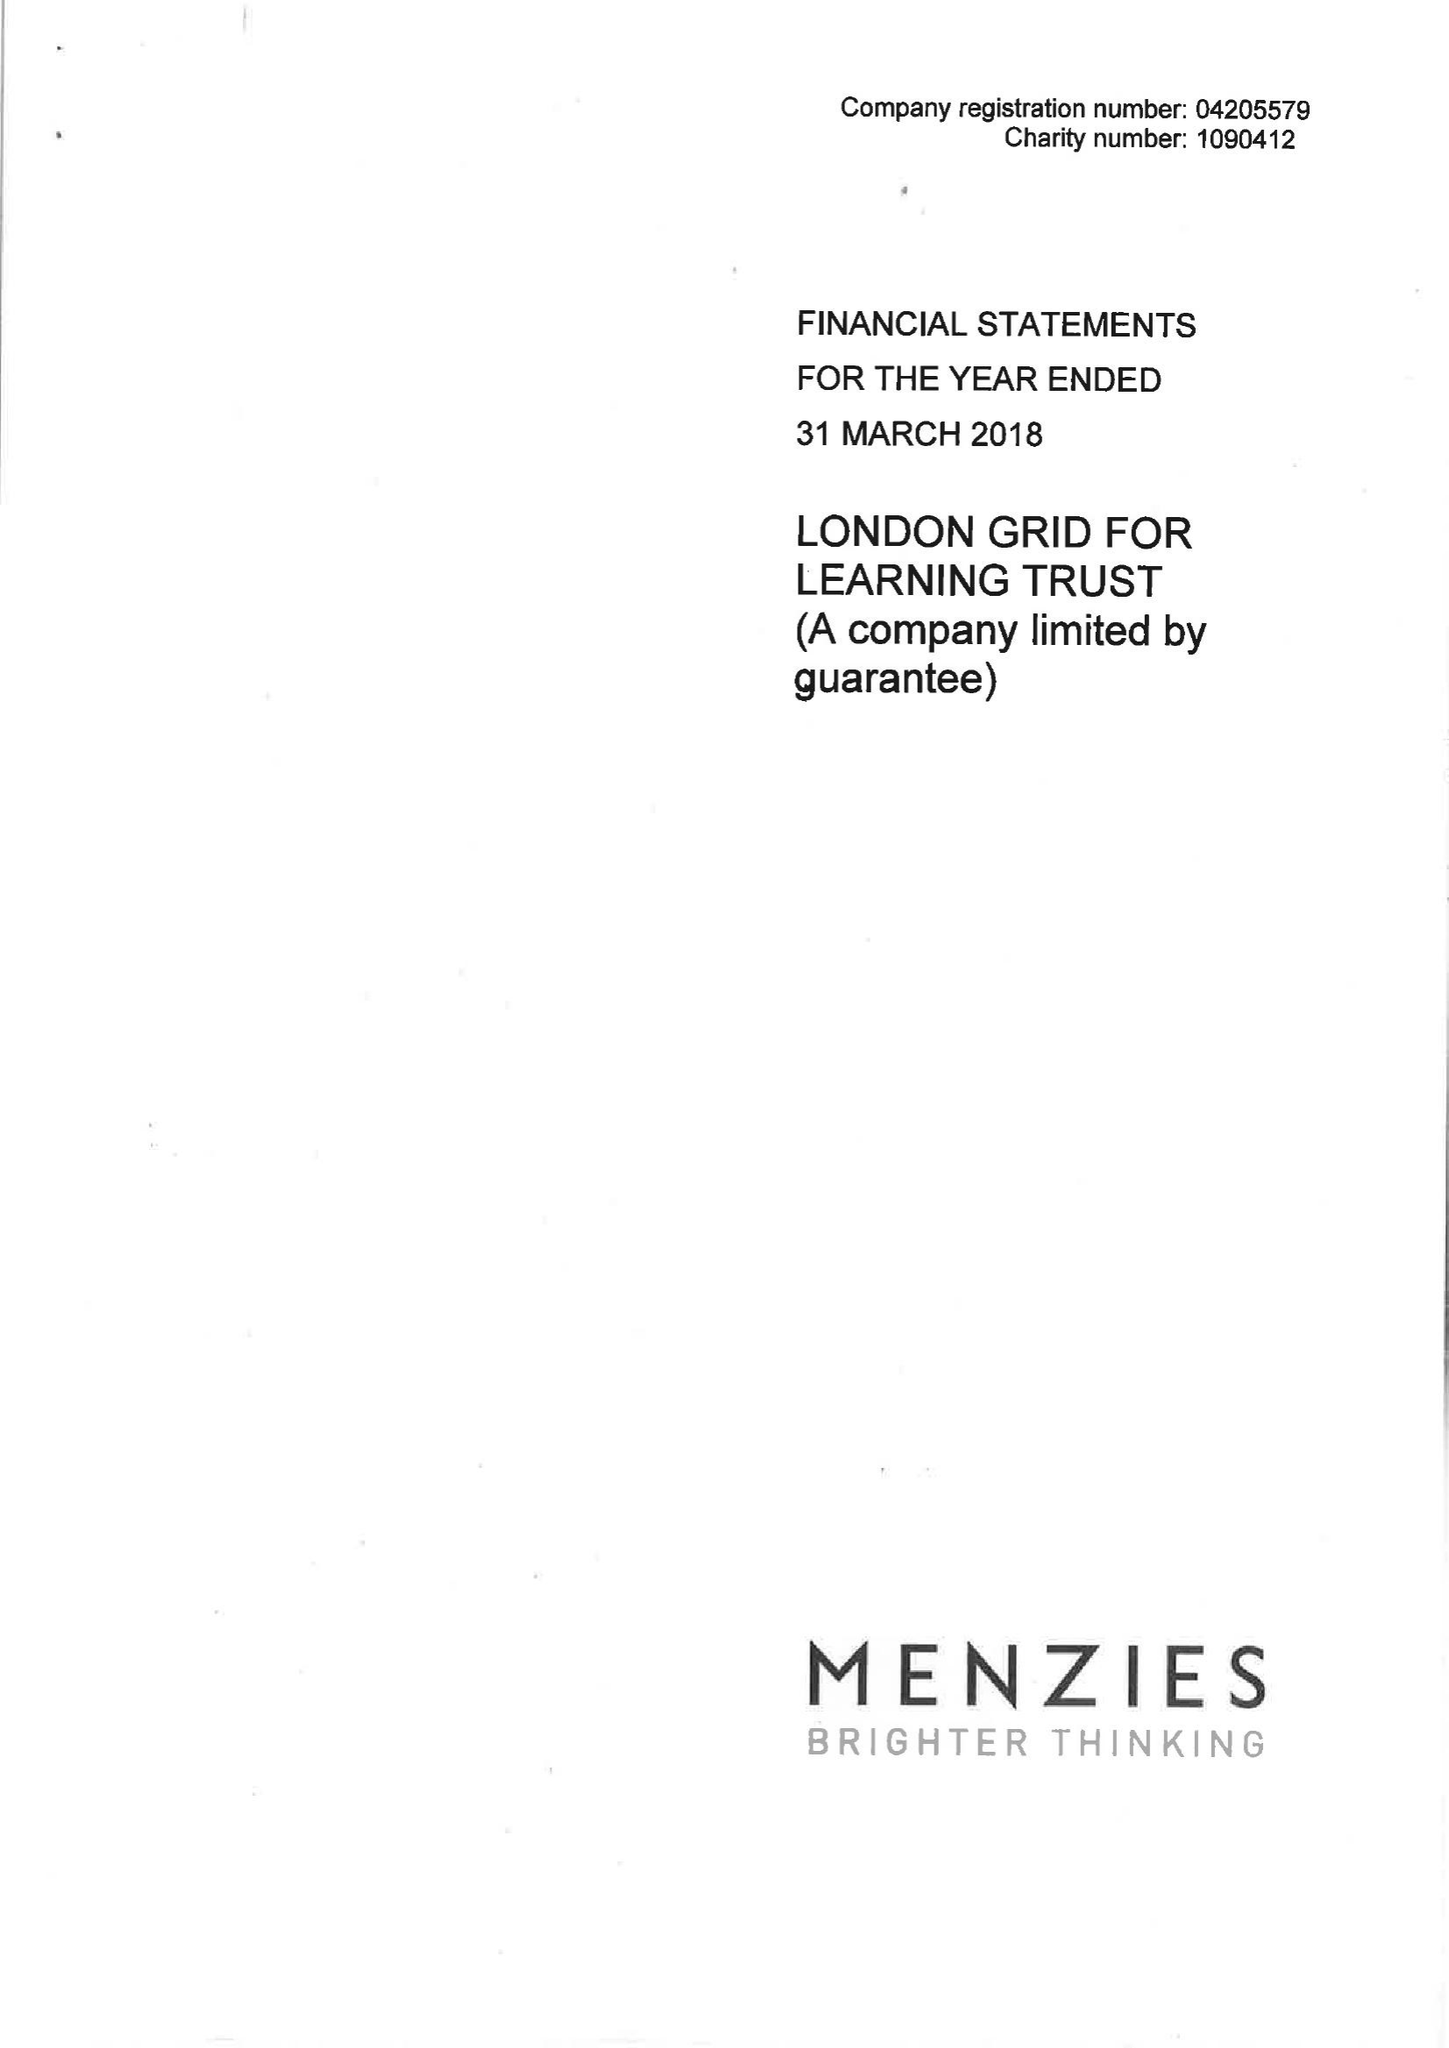What is the value for the spending_annually_in_british_pounds?
Answer the question using a single word or phrase. 25435000.00 